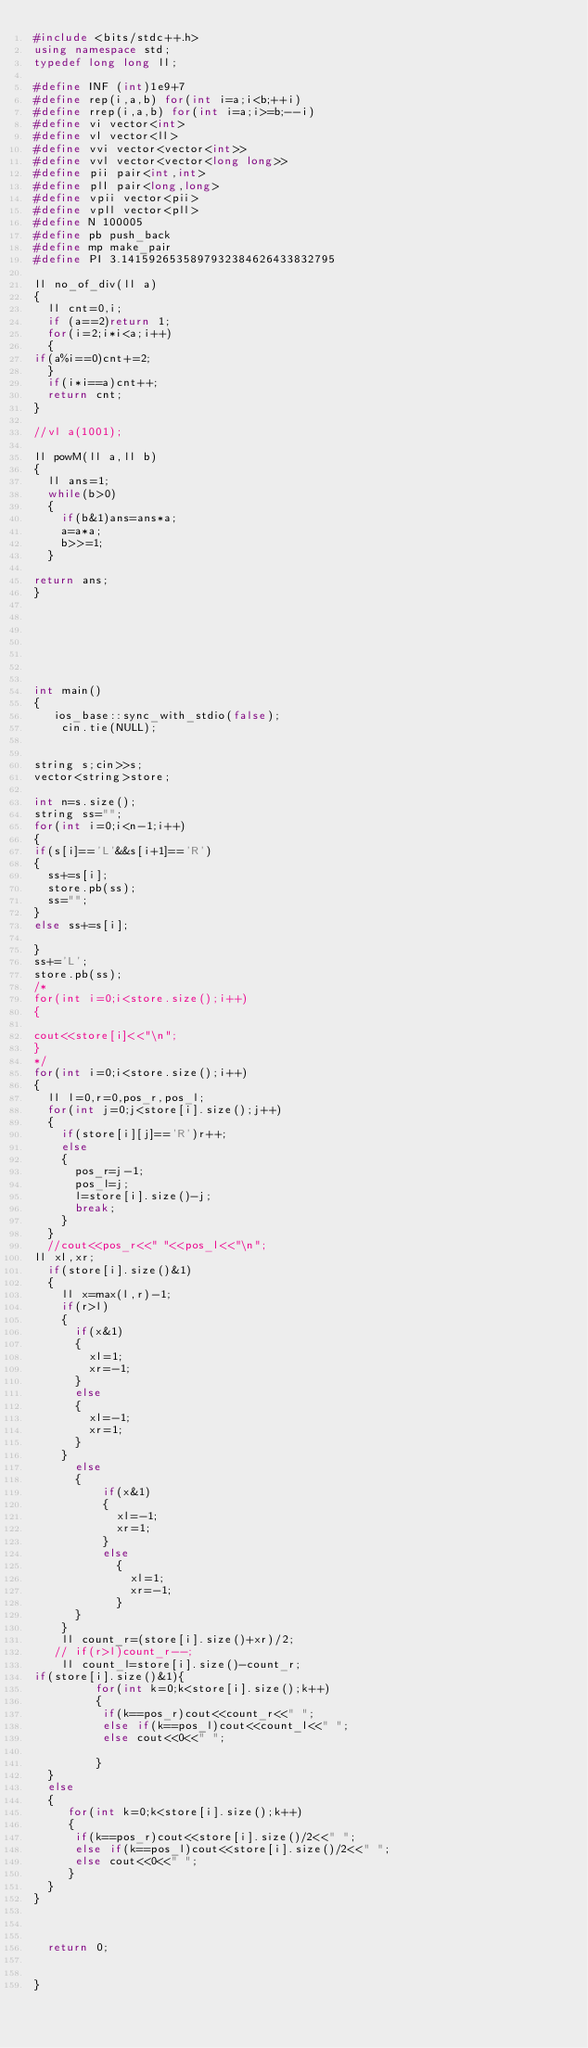<code> <loc_0><loc_0><loc_500><loc_500><_C++_>#include <bits/stdc++.h>
using namespace std;
typedef long long ll;

#define INF (int)1e9+7
#define rep(i,a,b) for(int i=a;i<b;++i)
#define rrep(i,a,b) for(int i=a;i>=b;--i)
#define vi vector<int>
#define vl vector<ll>
#define vvi vector<vector<int>>
#define vvl vector<vector<long long>>
#define pii pair<int,int>
#define pll pair<long,long>
#define vpii vector<pii>
#define vpll vector<pll>
#define N 100005
#define pb push_back
#define mp make_pair
#define PI 3.1415926535897932384626433832795

ll no_of_div(ll a)
{
  ll cnt=0,i;
  if (a==2)return 1;
  for(i=2;i*i<a;i++)
  {
if(a%i==0)cnt+=2;
  }
  if(i*i==a)cnt++;
  return cnt;
}

//vl a(1001);

ll powM(ll a,ll b)
{ 
  ll ans=1;
  while(b>0)
  {
    if(b&1)ans=ans*a;
    a=a*a;
    b>>=1;
  }

return ans;
}







int main()
{
   ios_base::sync_with_stdio(false);
    cin.tie(NULL);


string s;cin>>s;
vector<string>store;

int n=s.size();
string ss="";
for(int i=0;i<n-1;i++)
{
if(s[i]=='L'&&s[i+1]=='R')
{
  ss+=s[i];
  store.pb(ss);
  ss="";
}
else ss+=s[i];

}
ss+='L';
store.pb(ss);
/*
for(int i=0;i<store.size();i++)
{

cout<<store[i]<<"\n";
}
*/
for(int i=0;i<store.size();i++)
{
  ll l=0,r=0,pos_r,pos_l;
  for(int j=0;j<store[i].size();j++)
  {
    if(store[i][j]=='R')r++;
    else 
    {
      pos_r=j-1;
      pos_l=j;
      l=store[i].size()-j;
      break;
    }
  }
  //cout<<pos_r<<" "<<pos_l<<"\n";
ll xl,xr;
  if(store[i].size()&1)
  {
    ll x=max(l,r)-1;
    if(r>l)
    {
      if(x&1)
      {
        xl=1;
        xr=-1;
      }
      else 
      {
        xl=-1;
        xr=1;
      }
    }
      else 
      {
          if(x&1)
          {
            xl=-1;
            xr=1;
          }
          else
            {
              xl=1;
              xr=-1;
            }
      }
    }
    ll count_r=(store[i].size()+xr)/2;
   // if(r>l)count_r--;
    ll count_l=store[i].size()-count_r;
if(store[i].size()&1){
         for(int k=0;k<store[i].size();k++)
         {
          if(k==pos_r)cout<<count_r<<" ";
          else if(k==pos_l)cout<<count_l<<" ";
          else cout<<0<<" ";
        
         }
  }
  else 
  {
     for(int k=0;k<store[i].size();k++)
     {
      if(k==pos_r)cout<<store[i].size()/2<<" ";
      else if(k==pos_l)cout<<store[i].size()/2<<" ";
      else cout<<0<<" ";
     }
  }
}



  return 0;


}</code> 